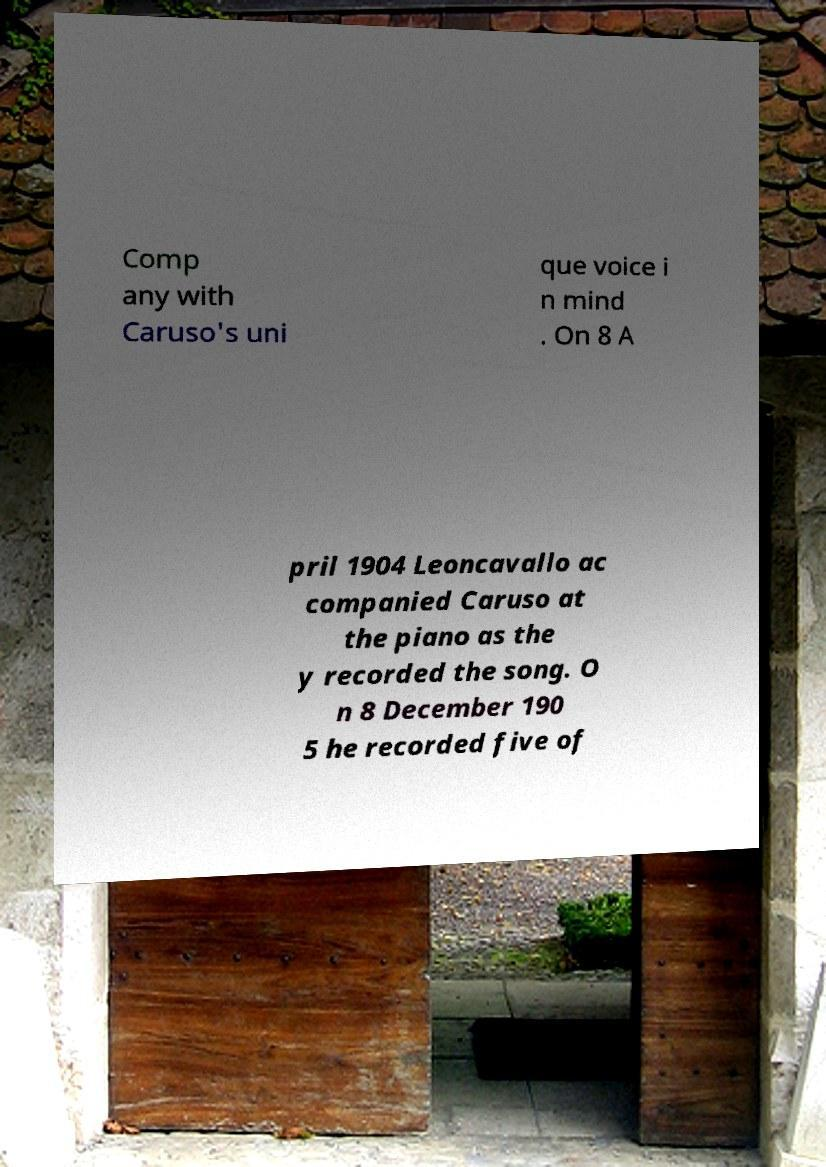Can you read and provide the text displayed in the image?This photo seems to have some interesting text. Can you extract and type it out for me? Comp any with Caruso's uni que voice i n mind . On 8 A pril 1904 Leoncavallo ac companied Caruso at the piano as the y recorded the song. O n 8 December 190 5 he recorded five of 